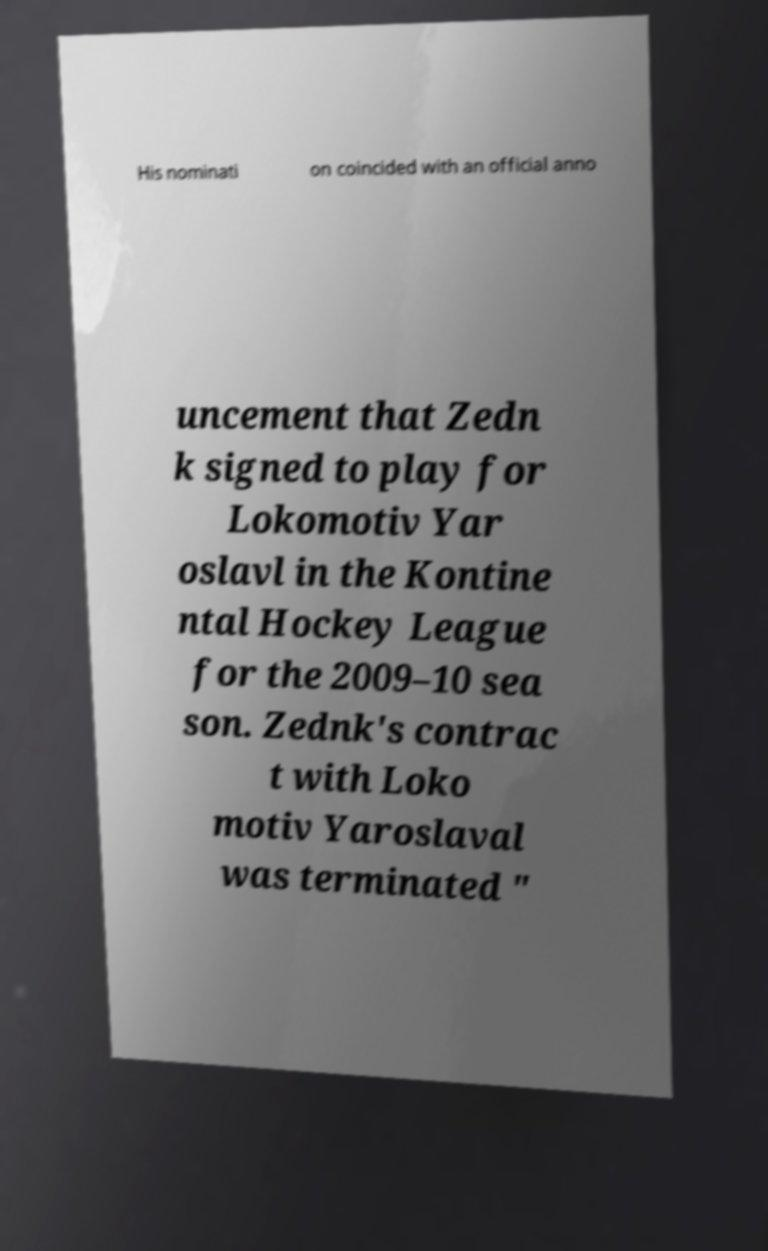Please identify and transcribe the text found in this image. His nominati on coincided with an official anno uncement that Zedn k signed to play for Lokomotiv Yar oslavl in the Kontine ntal Hockey League for the 2009–10 sea son. Zednk's contrac t with Loko motiv Yaroslaval was terminated " 